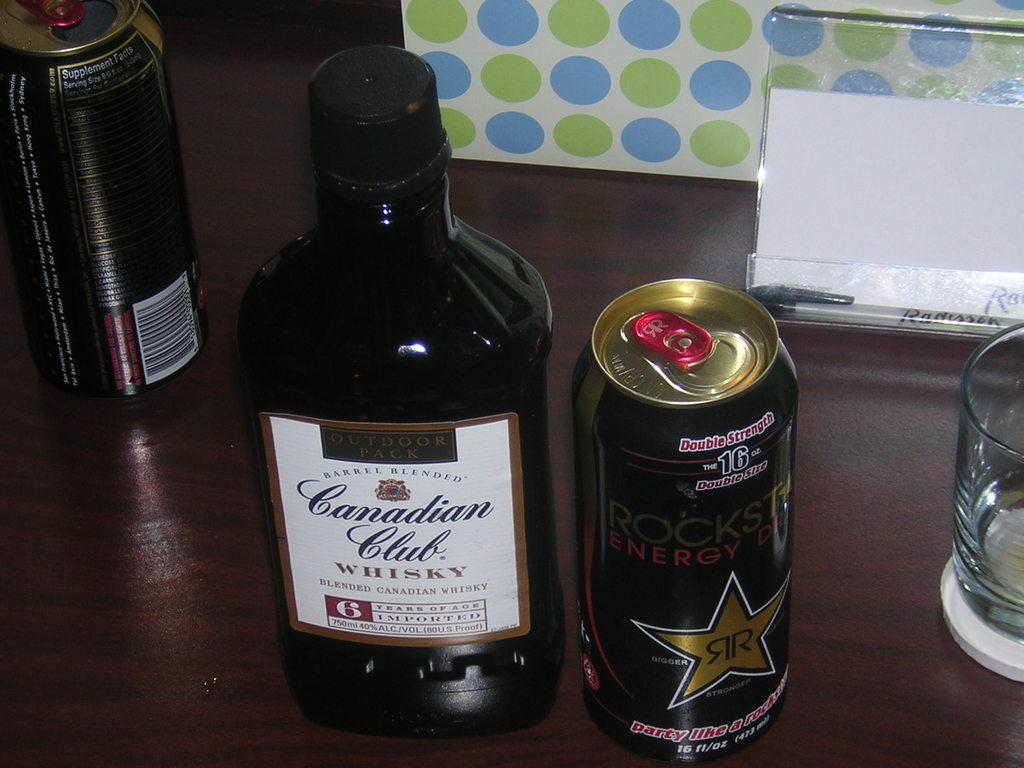<image>
Describe the image concisely. the words Canadian Club that are on a bottle 